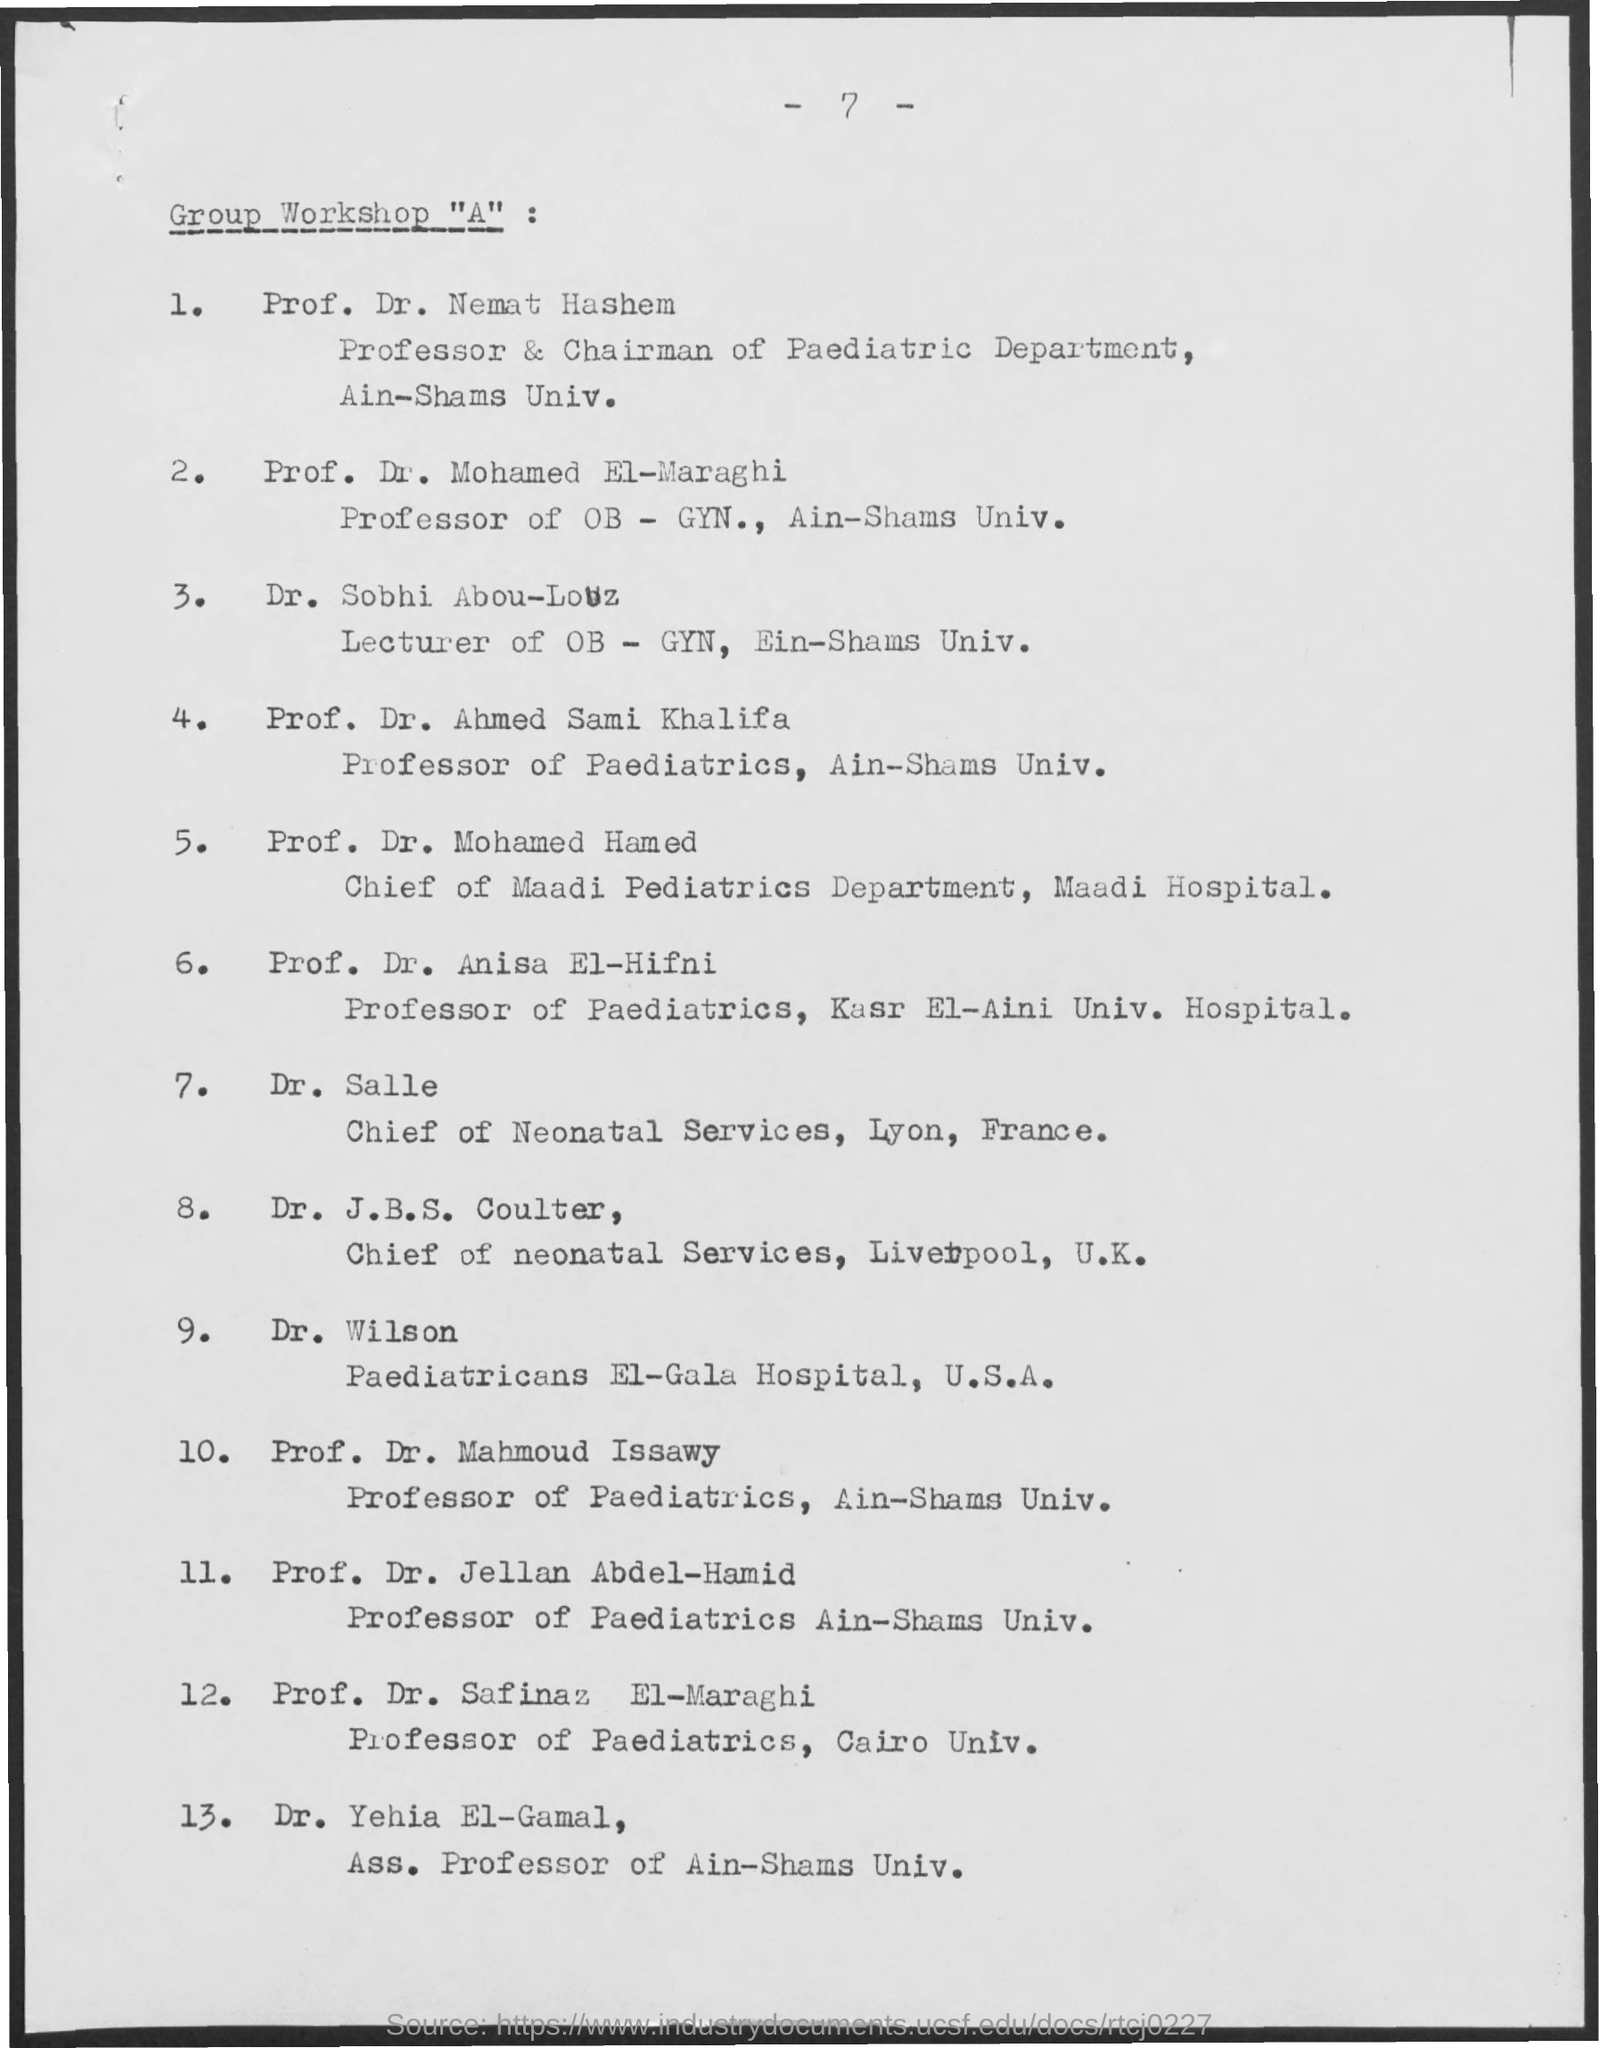Who is the chairman of the paediatric department in ain-shams univ. ?
Your answer should be compact. Dr. nemat hashem. What is the profession of the dr. mohamed el-maraghi ?
Ensure brevity in your answer.  Professor of ob - gyn. Who is the chief of neonatal services in lyon ?
Give a very brief answer. Dr. salle. Who is the paediatricans at el-gala hospital ?
Your response must be concise. Dr. Wilson. Who is the professor of paediatrics in cairo univ. ?
Provide a short and direct response. Prof. Dr. safinaz EL-Maraghi. 